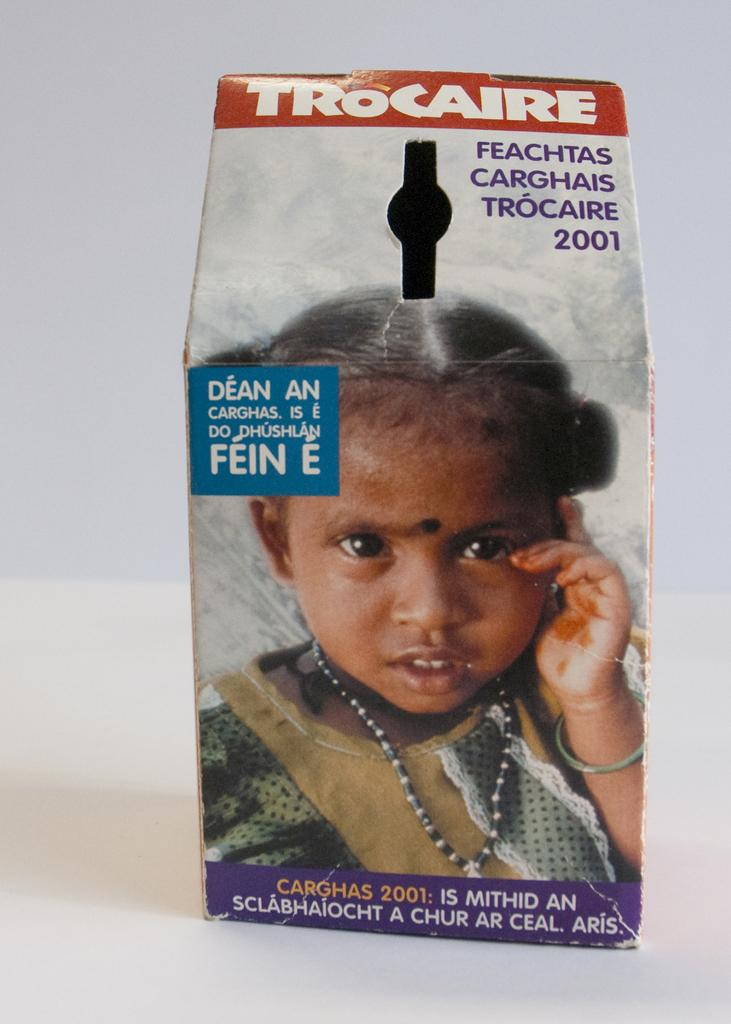What object is present in the image? There is a box in the image. What is depicted on the surface of the box? There is an image on the box. Are there any words or letters on the box? Yes, there is text written on the box. What is the opinion of the gate about the box in the image? There is no gate present in the image, so it cannot have an opinion about the box. 